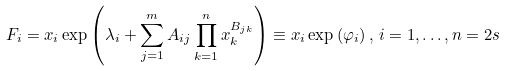Convert formula to latex. <formula><loc_0><loc_0><loc_500><loc_500>F _ { i } = x _ { i } \exp \left ( \lambda _ { i } + \sum _ { j = 1 } ^ { m } A _ { i j } \prod _ { k = 1 } ^ { n } x _ { k } ^ { B _ { j k } } \right ) \equiv x _ { i } \exp { ( \varphi _ { i } ) } \, , \, i = 1 , \dots , n = 2 s</formula> 